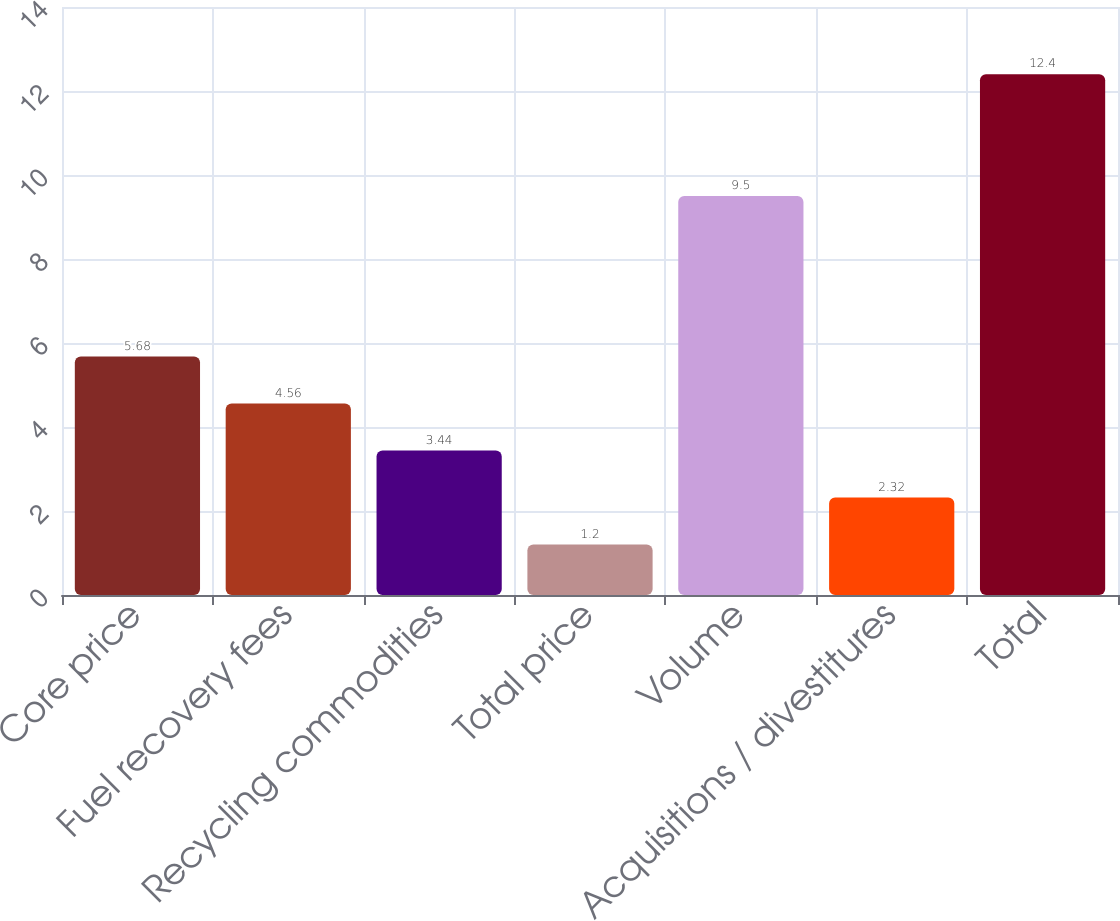<chart> <loc_0><loc_0><loc_500><loc_500><bar_chart><fcel>Core price<fcel>Fuel recovery fees<fcel>Recycling commodities<fcel>Total price<fcel>Volume<fcel>Acquisitions / divestitures<fcel>Total<nl><fcel>5.68<fcel>4.56<fcel>3.44<fcel>1.2<fcel>9.5<fcel>2.32<fcel>12.4<nl></chart> 